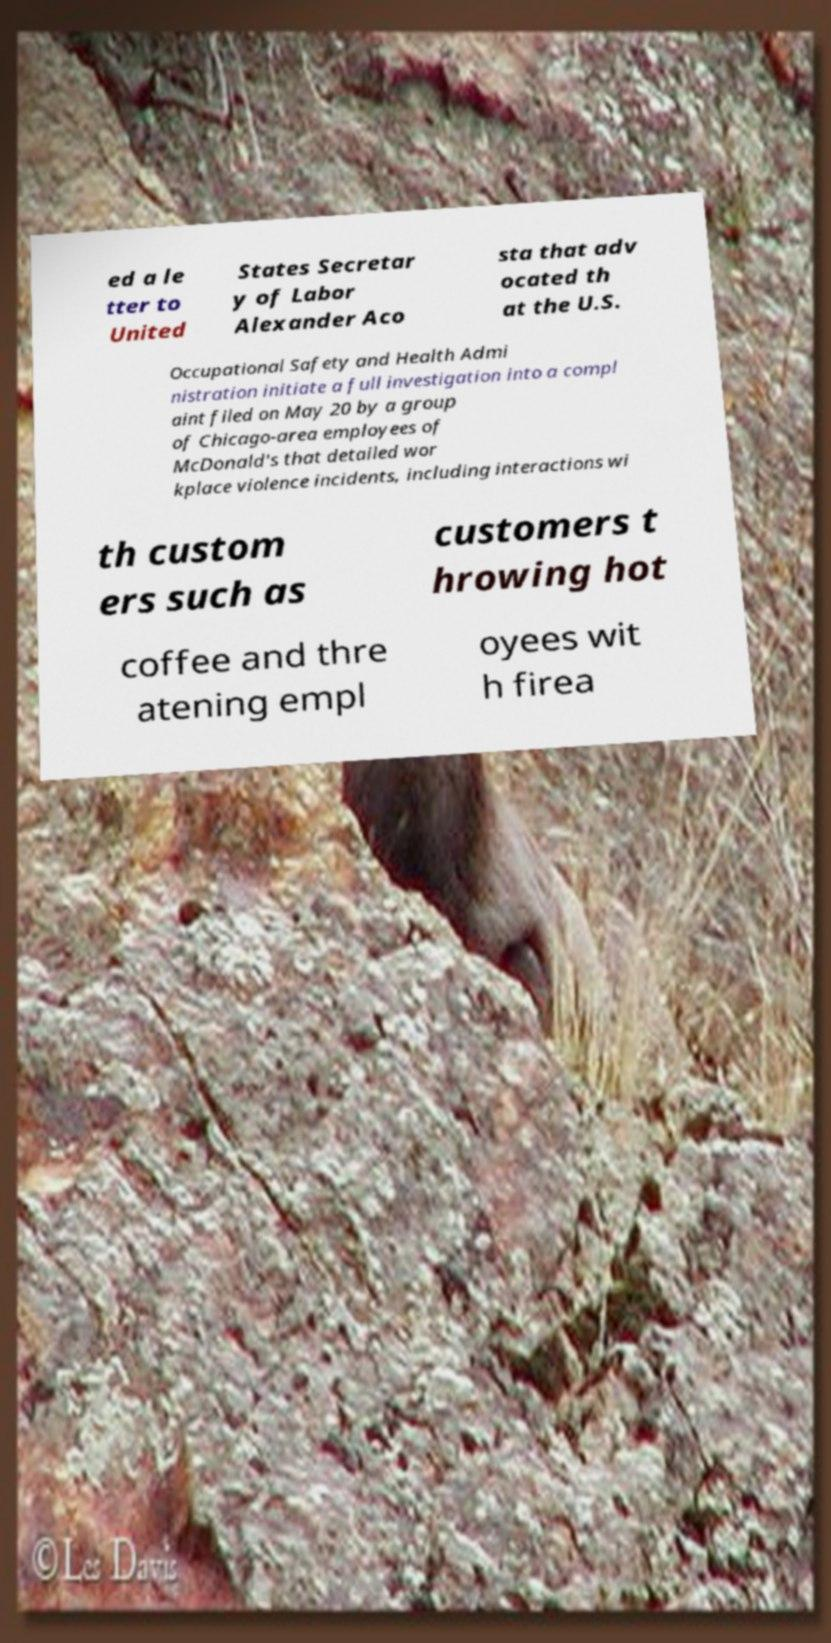I need the written content from this picture converted into text. Can you do that? ed a le tter to United States Secretar y of Labor Alexander Aco sta that adv ocated th at the U.S. Occupational Safety and Health Admi nistration initiate a full investigation into a compl aint filed on May 20 by a group of Chicago-area employees of McDonald's that detailed wor kplace violence incidents, including interactions wi th custom ers such as customers t hrowing hot coffee and thre atening empl oyees wit h firea 